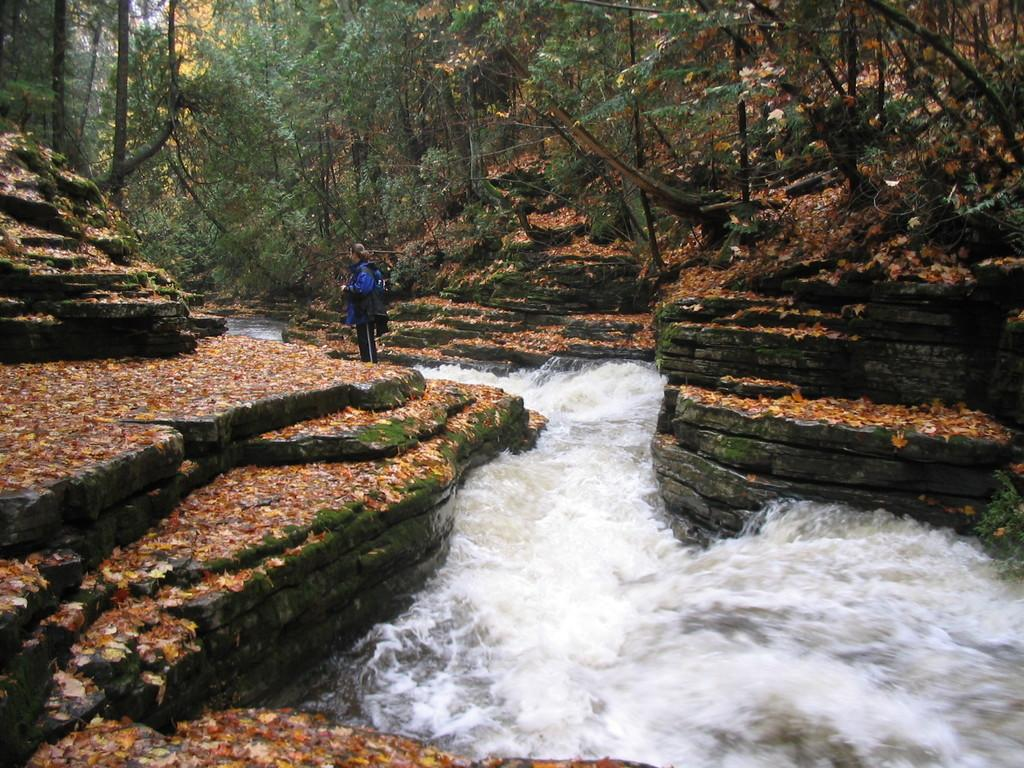Who is the main subject in the image? There is a woman standing in the center of the image. What is the woman standing on? The woman is standing on the ground. What can be seen at the bottom of the image? Leaves and water are visible at the bottom of the image. What is visible in the background of the image? There is water and trees present in the background of the image. What type of vegetation can be seen in the background? Plants are visible in the background of the image. Where is the mailbox located in the image? There is no mailbox present in the image. What type of recess activity is taking place in the image? There is no recess activity depicted in the image. 